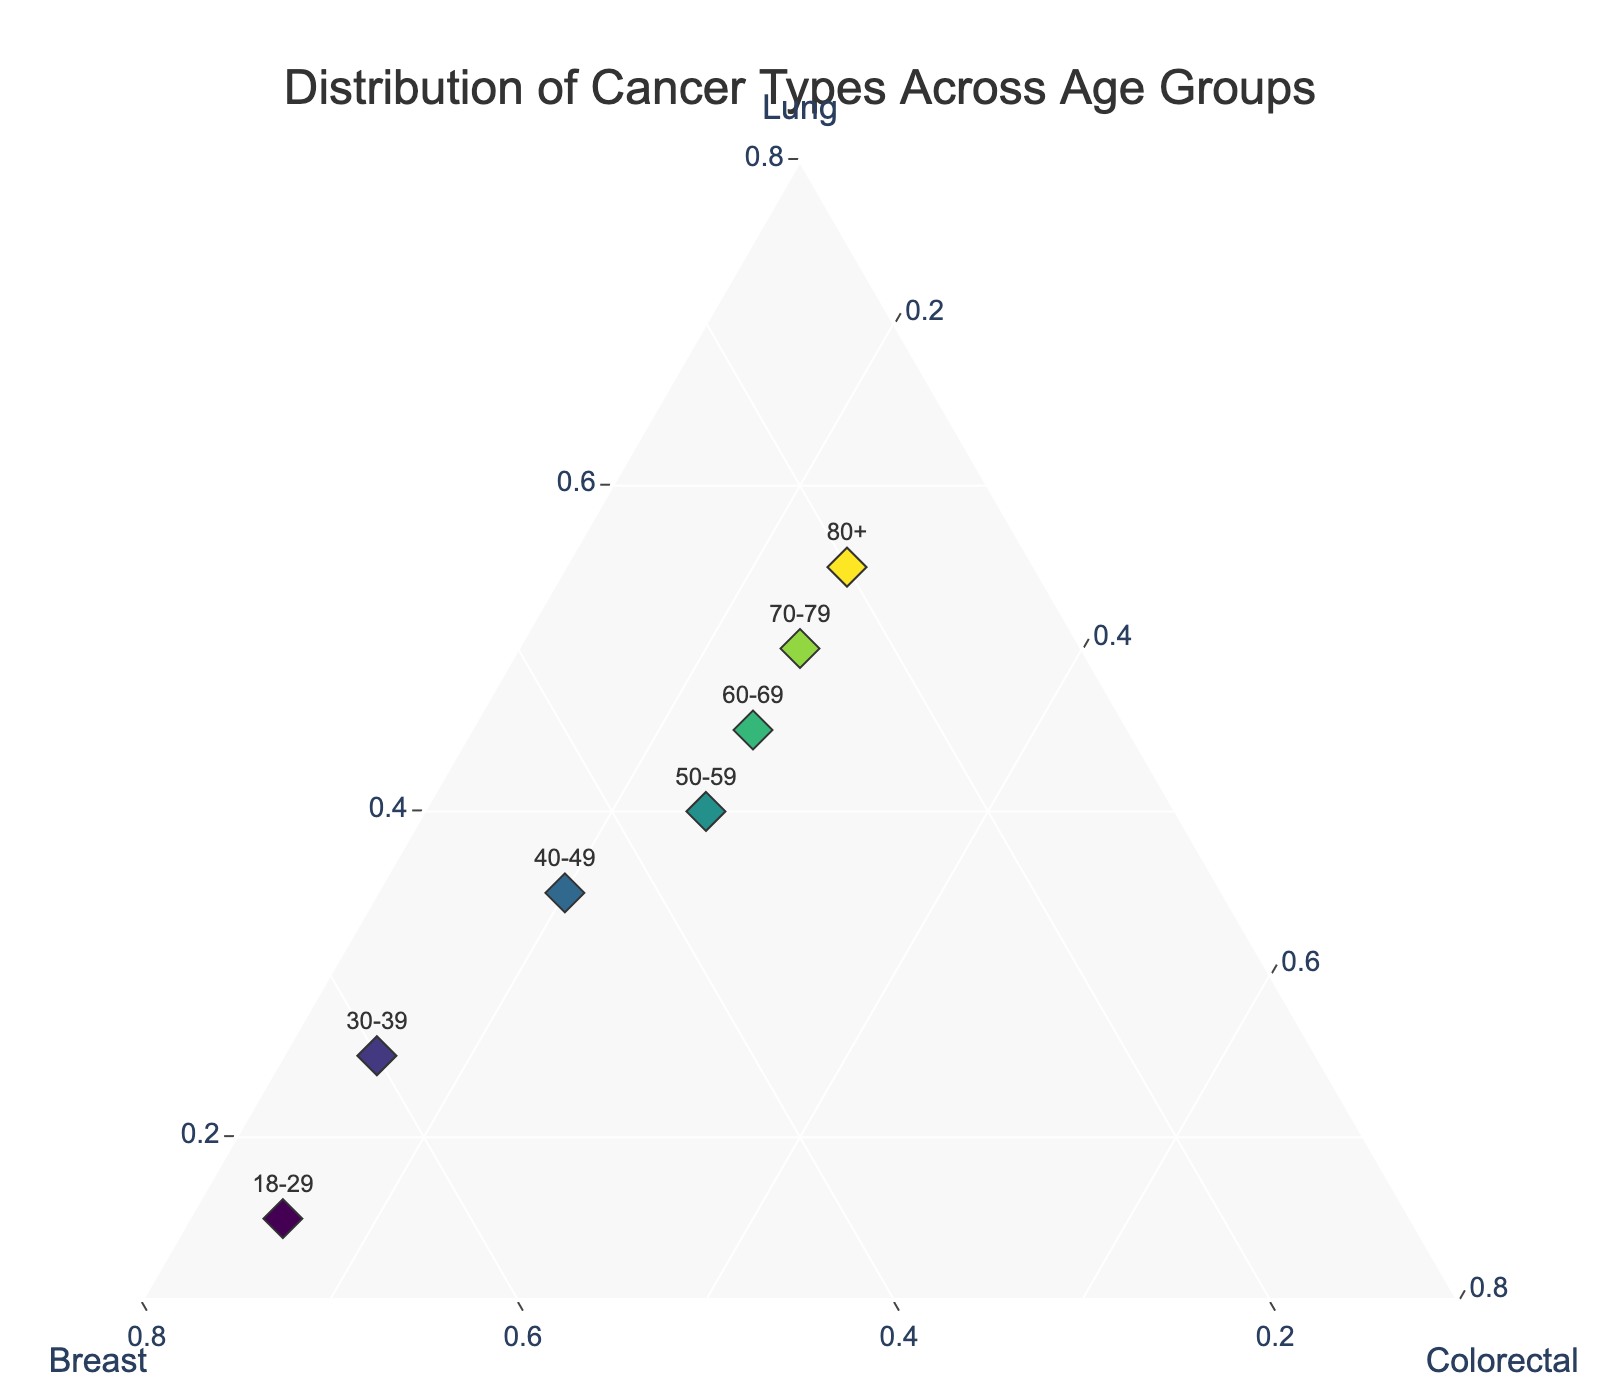What is the title of the figure? The title of the figure is displayed prominently at the top, often with larger text.
Answer: Distribution of Cancer Types Across Age Groups What are the three axes labeled as in the ternary plot? The labels for the three axes are indicated around the edges of the triangular plot.
Answer: Lung, Breast, Colorectal How many age groups are represented in the plot? Each age group is represented by a labeled data point within the ternary plot. Count the unique labels.
Answer: 7 Which age group has the highest proportion of lung cancer? Identify the data point closest to the 'Lung' axis, where the value of 'Lung' is highest. Read the label associated with this point.
Answer: 80+ Which two age groups have the same proportion of colorectal cancer? Look for data points along a line parallel to the 'Colorectal' axis with equal c-axis values.
Answer: 50-59, 60-69, 70-79, 80+ How does the proportion of breast cancer change from the youngest to the oldest age group? Trace the labeled data points from the youngest to the oldest age group, noting the shift along the 'Breast' axis.
Answer: Decreases Is there any age group where the proportions of lung, breast, and colorectal cancer are equal? Identify any point that lies at the center of the ternary plot where all axes would have approximately equal values. Check if it corresponds to any age group.
Answer: No Which cancer type shows an increasing trend with age? Look across the age groups and observe which axis values increase consistently from youngest to oldest groups.
Answer: Lung What's the average proportion of breast cancer across all age groups? Sum the 'Breast' values for all age groups and divide by the number of age groups.
Answer: 0.41 In the age group 40-49, which cancer type has the lowest proportion? Refer to the data point for age group 40-49 and identify the smallest value among the three cancer types.
Answer: Colorectal 